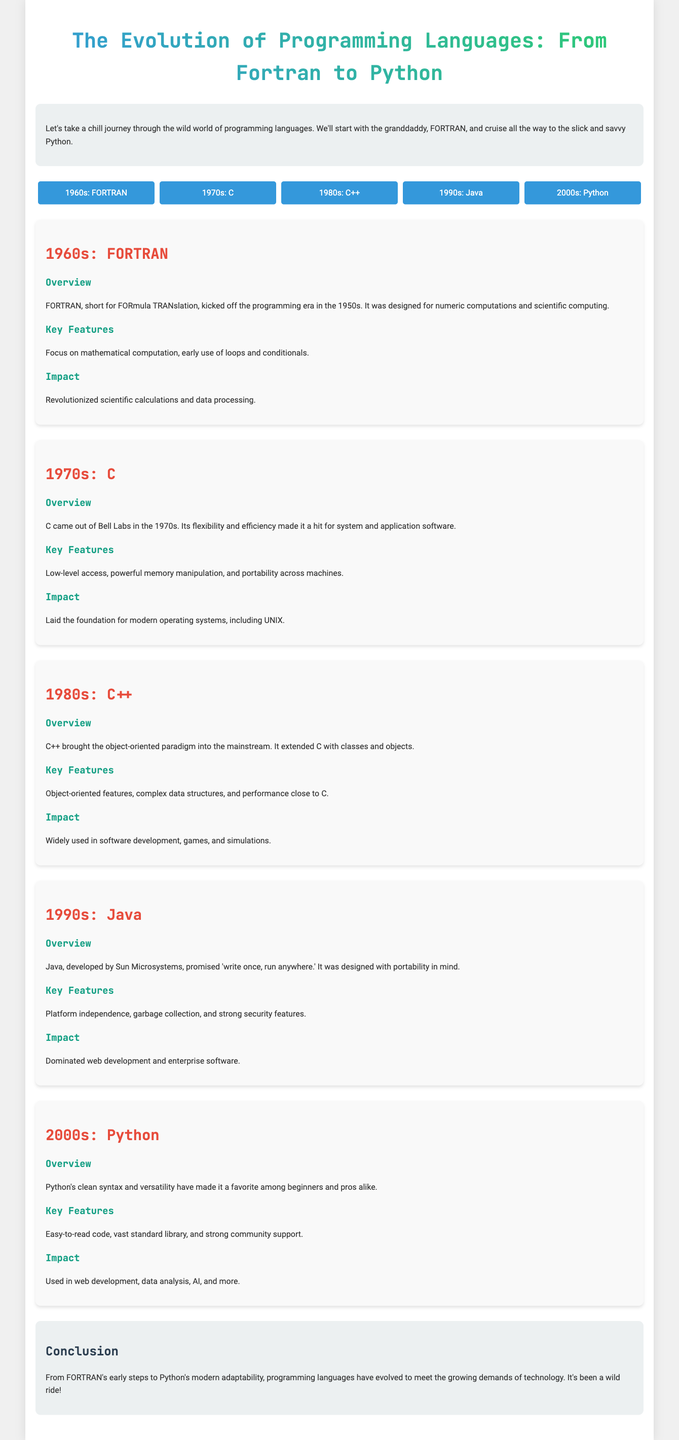What programming language was introduced in the 1960s? The document states that FORTRAN was introduced in the 1960s.
Answer: FORTRAN What is the main focus of FORTRAN? The infographic highlights that FORTRAN was designed for numeric computations and scientific computing.
Answer: Numeric computations Which programming language is associated with the 1970s? The document lists C as the programming language from the 1970s.
Answer: C What was a significant impact of the C programming language? According to the infographic, it laid the foundation for modern operating systems, including UNIX.
Answer: Modern operating systems Which programming language introduced the object-oriented paradigm? The document mentions C++ as the language that brought the object-oriented paradigm into the mainstream.
Answer: C++ What key feature does Java offer? The infographic states that Java is known for its platform independence.
Answer: Platform independence What decade is Python associated with? The document lists Python as the programming language from the 2000s.
Answer: 2000s What impact did Python have according to the infographic? The document indicates that Python is used in web development, data analysis, AI, and more.
Answer: Web development, data analysis, AI What is the main theme of the infographic? The document conveys that the infographic is about the evolution of programming languages over time.
Answer: Evolution of programming languages 